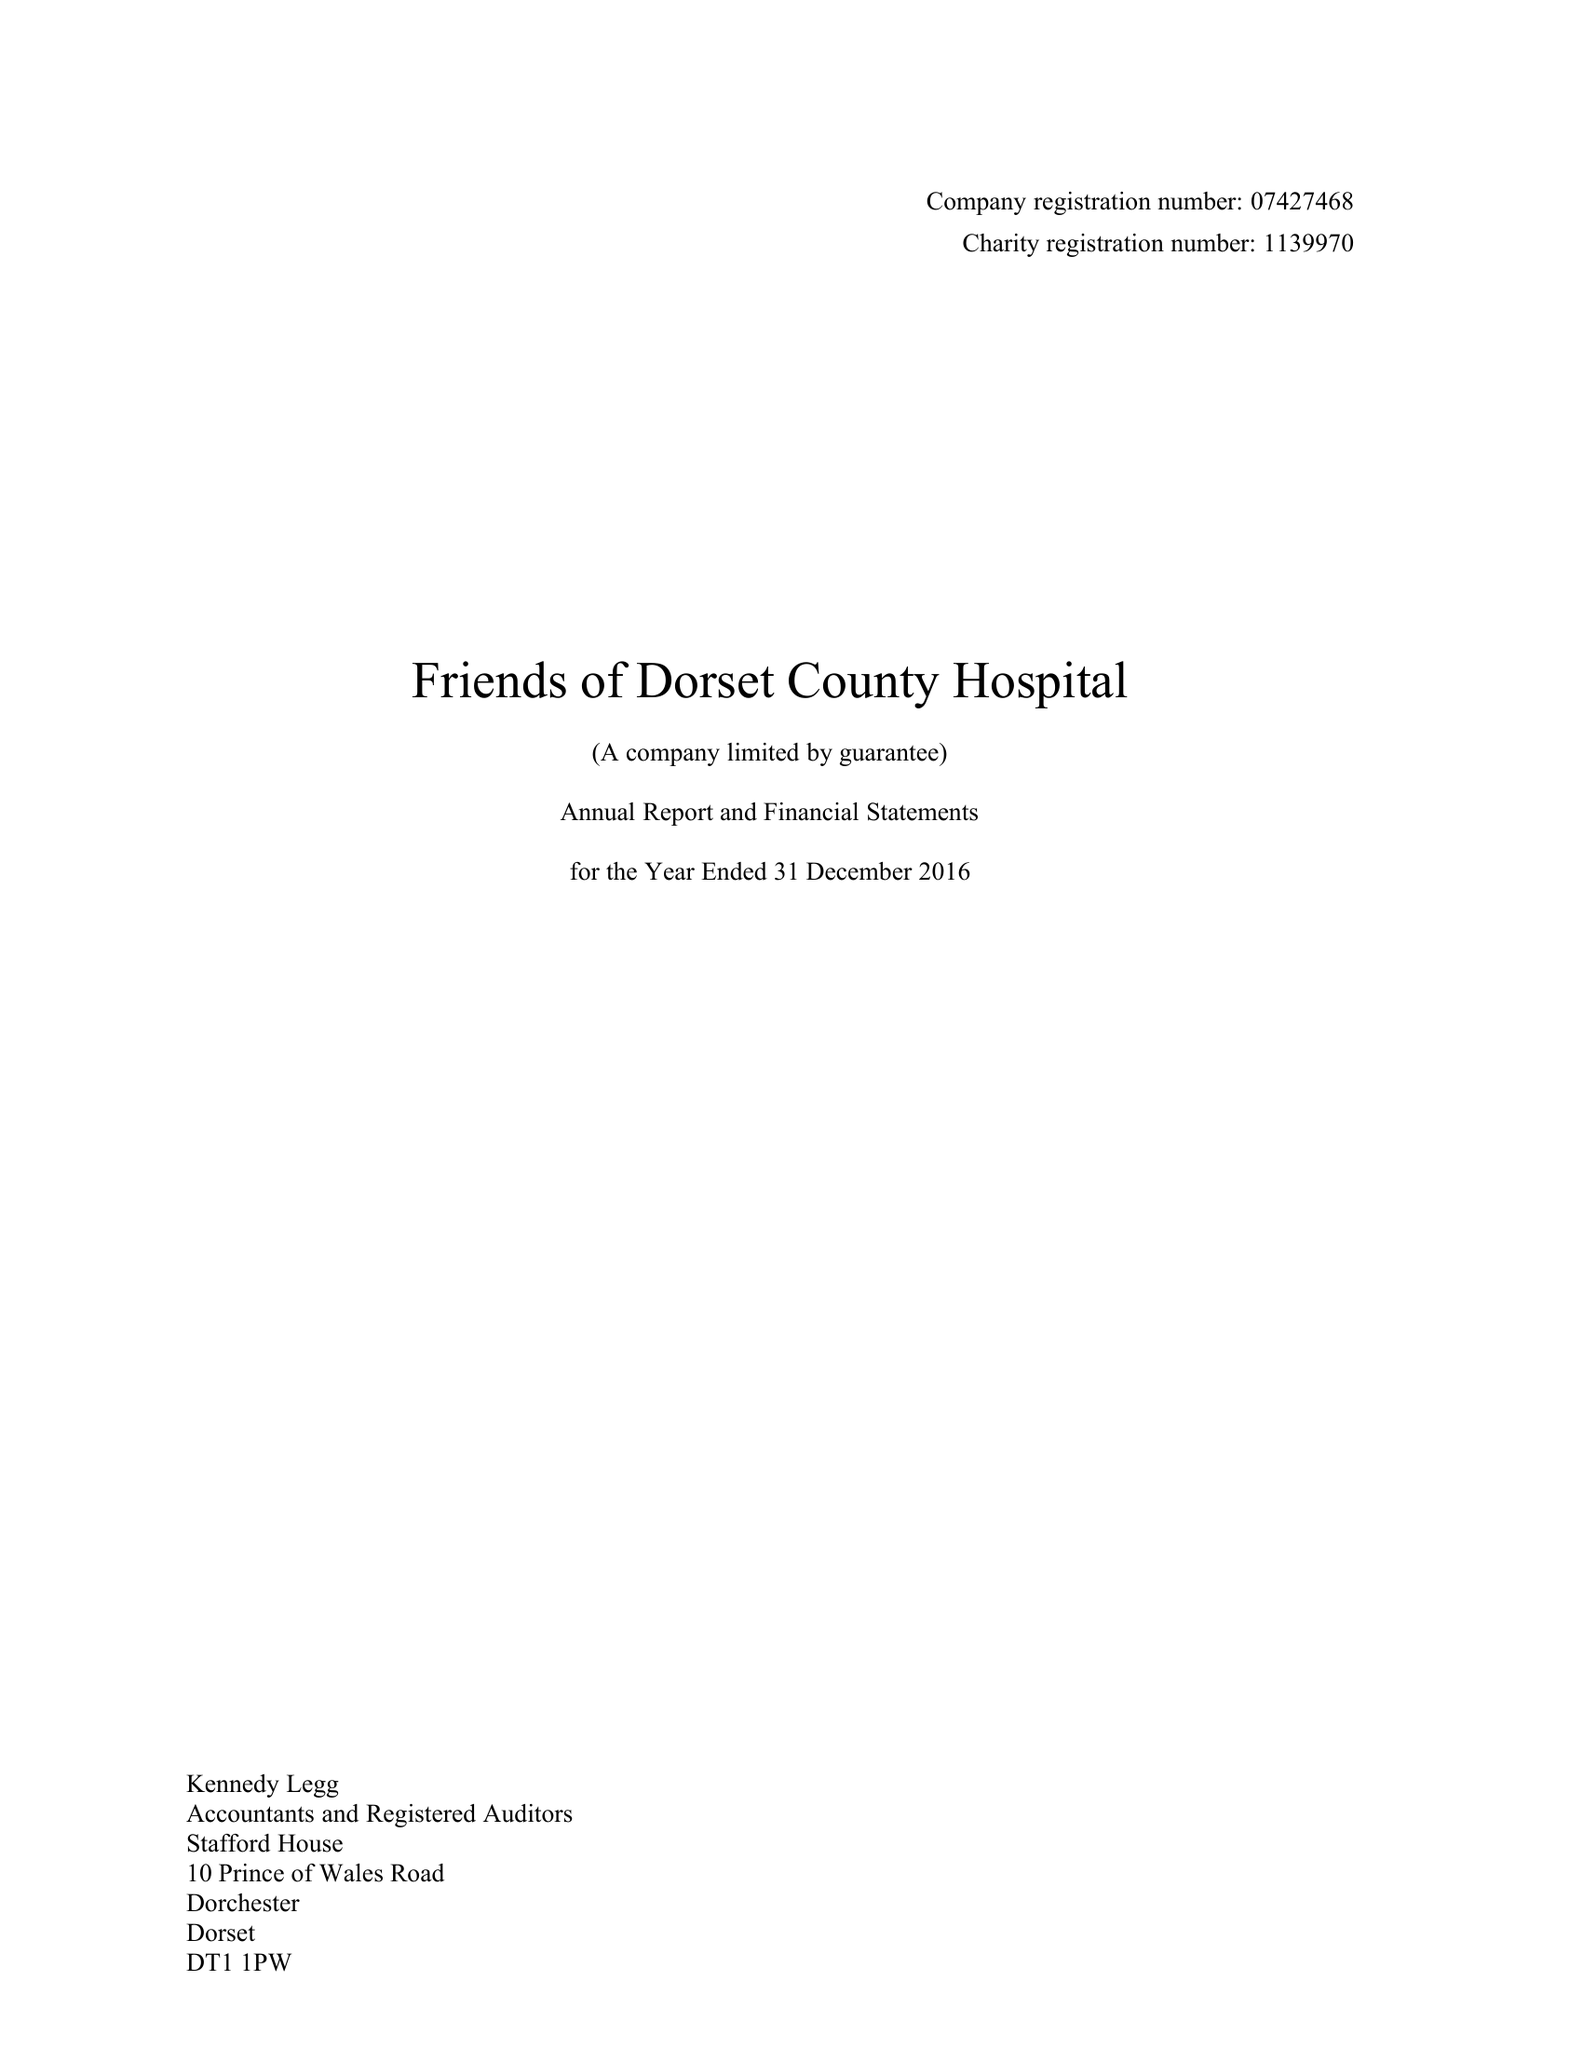What is the value for the spending_annually_in_british_pounds?
Answer the question using a single word or phrase. 229376.00 